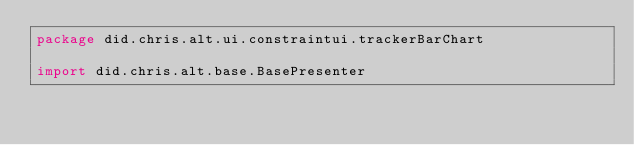<code> <loc_0><loc_0><loc_500><loc_500><_Kotlin_>package did.chris.alt.ui.constraintui.trackerBarChart

import did.chris.alt.base.BasePresenter</code> 